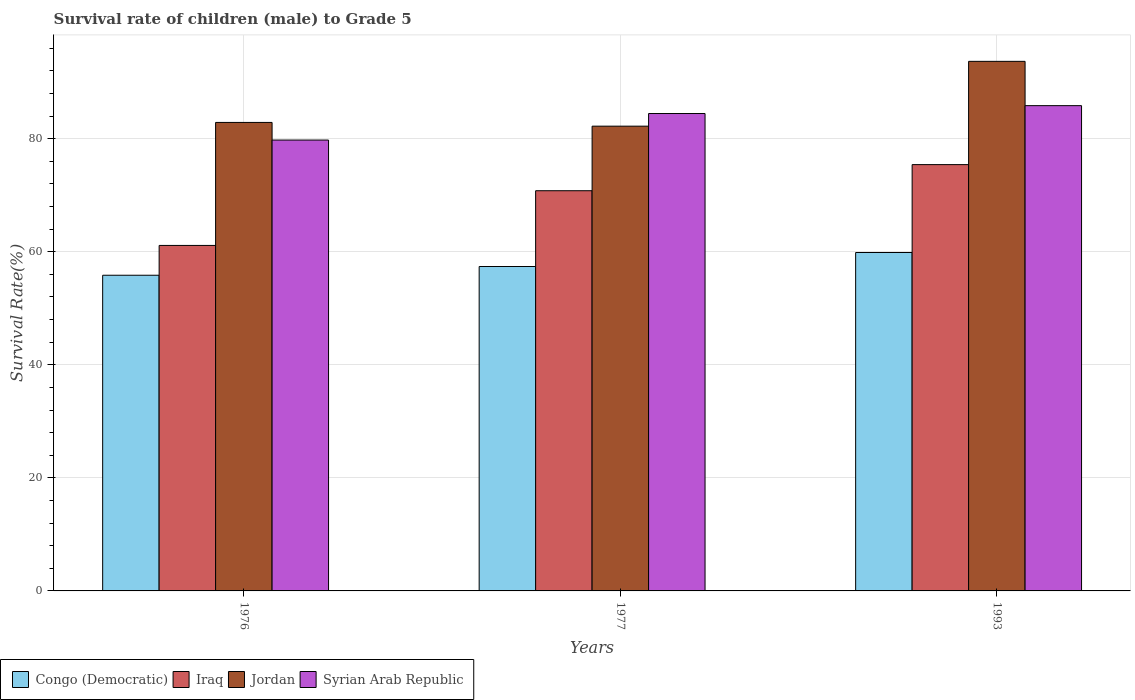How many different coloured bars are there?
Your answer should be very brief. 4. How many groups of bars are there?
Give a very brief answer. 3. How many bars are there on the 1st tick from the left?
Offer a terse response. 4. How many bars are there on the 3rd tick from the right?
Keep it short and to the point. 4. What is the label of the 2nd group of bars from the left?
Provide a short and direct response. 1977. In how many cases, is the number of bars for a given year not equal to the number of legend labels?
Provide a short and direct response. 0. What is the survival rate of male children to grade 5 in Congo (Democratic) in 1993?
Keep it short and to the point. 59.87. Across all years, what is the maximum survival rate of male children to grade 5 in Iraq?
Give a very brief answer. 75.42. Across all years, what is the minimum survival rate of male children to grade 5 in Jordan?
Your response must be concise. 82.22. In which year was the survival rate of male children to grade 5 in Syrian Arab Republic minimum?
Ensure brevity in your answer.  1976. What is the total survival rate of male children to grade 5 in Jordan in the graph?
Ensure brevity in your answer.  258.78. What is the difference between the survival rate of male children to grade 5 in Congo (Democratic) in 1976 and that in 1977?
Provide a short and direct response. -1.55. What is the difference between the survival rate of male children to grade 5 in Congo (Democratic) in 1993 and the survival rate of male children to grade 5 in Jordan in 1976?
Give a very brief answer. -23.01. What is the average survival rate of male children to grade 5 in Syrian Arab Republic per year?
Make the answer very short. 83.35. In the year 1977, what is the difference between the survival rate of male children to grade 5 in Syrian Arab Republic and survival rate of male children to grade 5 in Jordan?
Your response must be concise. 2.24. In how many years, is the survival rate of male children to grade 5 in Iraq greater than 12 %?
Your response must be concise. 3. What is the ratio of the survival rate of male children to grade 5 in Congo (Democratic) in 1976 to that in 1977?
Make the answer very short. 0.97. Is the survival rate of male children to grade 5 in Iraq in 1976 less than that in 1977?
Provide a succinct answer. Yes. Is the difference between the survival rate of male children to grade 5 in Syrian Arab Republic in 1977 and 1993 greater than the difference between the survival rate of male children to grade 5 in Jordan in 1977 and 1993?
Offer a terse response. Yes. What is the difference between the highest and the second highest survival rate of male children to grade 5 in Iraq?
Your response must be concise. 4.62. What is the difference between the highest and the lowest survival rate of male children to grade 5 in Iraq?
Offer a very short reply. 14.3. In how many years, is the survival rate of male children to grade 5 in Syrian Arab Republic greater than the average survival rate of male children to grade 5 in Syrian Arab Republic taken over all years?
Your answer should be compact. 2. Is the sum of the survival rate of male children to grade 5 in Syrian Arab Republic in 1976 and 1977 greater than the maximum survival rate of male children to grade 5 in Congo (Democratic) across all years?
Your response must be concise. Yes. What does the 4th bar from the left in 1993 represents?
Provide a short and direct response. Syrian Arab Republic. What does the 3rd bar from the right in 1977 represents?
Give a very brief answer. Iraq. How many bars are there?
Offer a terse response. 12. Are all the bars in the graph horizontal?
Offer a terse response. No. How many years are there in the graph?
Make the answer very short. 3. Are the values on the major ticks of Y-axis written in scientific E-notation?
Your response must be concise. No. Does the graph contain any zero values?
Make the answer very short. No. How many legend labels are there?
Offer a terse response. 4. What is the title of the graph?
Your answer should be very brief. Survival rate of children (male) to Grade 5. Does "Cameroon" appear as one of the legend labels in the graph?
Your answer should be compact. No. What is the label or title of the Y-axis?
Your response must be concise. Survival Rate(%). What is the Survival Rate(%) of Congo (Democratic) in 1976?
Your answer should be compact. 55.84. What is the Survival Rate(%) in Iraq in 1976?
Provide a short and direct response. 61.12. What is the Survival Rate(%) of Jordan in 1976?
Make the answer very short. 82.88. What is the Survival Rate(%) of Syrian Arab Republic in 1976?
Provide a succinct answer. 79.76. What is the Survival Rate(%) in Congo (Democratic) in 1977?
Offer a very short reply. 57.39. What is the Survival Rate(%) of Iraq in 1977?
Provide a succinct answer. 70.8. What is the Survival Rate(%) in Jordan in 1977?
Offer a very short reply. 82.22. What is the Survival Rate(%) of Syrian Arab Republic in 1977?
Provide a succinct answer. 84.45. What is the Survival Rate(%) in Congo (Democratic) in 1993?
Keep it short and to the point. 59.87. What is the Survival Rate(%) in Iraq in 1993?
Your answer should be compact. 75.42. What is the Survival Rate(%) in Jordan in 1993?
Your answer should be very brief. 93.68. What is the Survival Rate(%) of Syrian Arab Republic in 1993?
Offer a very short reply. 85.85. Across all years, what is the maximum Survival Rate(%) of Congo (Democratic)?
Provide a short and direct response. 59.87. Across all years, what is the maximum Survival Rate(%) of Iraq?
Keep it short and to the point. 75.42. Across all years, what is the maximum Survival Rate(%) in Jordan?
Provide a short and direct response. 93.68. Across all years, what is the maximum Survival Rate(%) of Syrian Arab Republic?
Provide a succinct answer. 85.85. Across all years, what is the minimum Survival Rate(%) in Congo (Democratic)?
Your answer should be very brief. 55.84. Across all years, what is the minimum Survival Rate(%) in Iraq?
Offer a very short reply. 61.12. Across all years, what is the minimum Survival Rate(%) of Jordan?
Offer a very short reply. 82.22. Across all years, what is the minimum Survival Rate(%) of Syrian Arab Republic?
Make the answer very short. 79.76. What is the total Survival Rate(%) in Congo (Democratic) in the graph?
Your answer should be compact. 173.1. What is the total Survival Rate(%) of Iraq in the graph?
Make the answer very short. 207.33. What is the total Survival Rate(%) of Jordan in the graph?
Ensure brevity in your answer.  258.78. What is the total Survival Rate(%) of Syrian Arab Republic in the graph?
Give a very brief answer. 250.06. What is the difference between the Survival Rate(%) of Congo (Democratic) in 1976 and that in 1977?
Give a very brief answer. -1.55. What is the difference between the Survival Rate(%) of Iraq in 1976 and that in 1977?
Ensure brevity in your answer.  -9.68. What is the difference between the Survival Rate(%) in Jordan in 1976 and that in 1977?
Your answer should be very brief. 0.66. What is the difference between the Survival Rate(%) in Syrian Arab Republic in 1976 and that in 1977?
Ensure brevity in your answer.  -4.69. What is the difference between the Survival Rate(%) of Congo (Democratic) in 1976 and that in 1993?
Provide a succinct answer. -4.02. What is the difference between the Survival Rate(%) of Iraq in 1976 and that in 1993?
Provide a short and direct response. -14.3. What is the difference between the Survival Rate(%) of Jordan in 1976 and that in 1993?
Keep it short and to the point. -10.81. What is the difference between the Survival Rate(%) of Syrian Arab Republic in 1976 and that in 1993?
Provide a succinct answer. -6.09. What is the difference between the Survival Rate(%) in Congo (Democratic) in 1977 and that in 1993?
Give a very brief answer. -2.48. What is the difference between the Survival Rate(%) in Iraq in 1977 and that in 1993?
Your answer should be compact. -4.62. What is the difference between the Survival Rate(%) in Jordan in 1977 and that in 1993?
Your answer should be very brief. -11.46. What is the difference between the Survival Rate(%) of Syrian Arab Republic in 1977 and that in 1993?
Your answer should be very brief. -1.39. What is the difference between the Survival Rate(%) in Congo (Democratic) in 1976 and the Survival Rate(%) in Iraq in 1977?
Your response must be concise. -14.95. What is the difference between the Survival Rate(%) in Congo (Democratic) in 1976 and the Survival Rate(%) in Jordan in 1977?
Your answer should be very brief. -26.37. What is the difference between the Survival Rate(%) in Congo (Democratic) in 1976 and the Survival Rate(%) in Syrian Arab Republic in 1977?
Offer a terse response. -28.61. What is the difference between the Survival Rate(%) in Iraq in 1976 and the Survival Rate(%) in Jordan in 1977?
Offer a terse response. -21.1. What is the difference between the Survival Rate(%) in Iraq in 1976 and the Survival Rate(%) in Syrian Arab Republic in 1977?
Provide a short and direct response. -23.34. What is the difference between the Survival Rate(%) of Jordan in 1976 and the Survival Rate(%) of Syrian Arab Republic in 1977?
Your answer should be compact. -1.58. What is the difference between the Survival Rate(%) in Congo (Democratic) in 1976 and the Survival Rate(%) in Iraq in 1993?
Your answer should be very brief. -19.57. What is the difference between the Survival Rate(%) of Congo (Democratic) in 1976 and the Survival Rate(%) of Jordan in 1993?
Ensure brevity in your answer.  -37.84. What is the difference between the Survival Rate(%) of Congo (Democratic) in 1976 and the Survival Rate(%) of Syrian Arab Republic in 1993?
Your answer should be compact. -30. What is the difference between the Survival Rate(%) of Iraq in 1976 and the Survival Rate(%) of Jordan in 1993?
Offer a terse response. -32.56. What is the difference between the Survival Rate(%) of Iraq in 1976 and the Survival Rate(%) of Syrian Arab Republic in 1993?
Your answer should be compact. -24.73. What is the difference between the Survival Rate(%) of Jordan in 1976 and the Survival Rate(%) of Syrian Arab Republic in 1993?
Your response must be concise. -2.97. What is the difference between the Survival Rate(%) of Congo (Democratic) in 1977 and the Survival Rate(%) of Iraq in 1993?
Offer a terse response. -18.03. What is the difference between the Survival Rate(%) of Congo (Democratic) in 1977 and the Survival Rate(%) of Jordan in 1993?
Ensure brevity in your answer.  -36.29. What is the difference between the Survival Rate(%) in Congo (Democratic) in 1977 and the Survival Rate(%) in Syrian Arab Republic in 1993?
Your answer should be very brief. -28.46. What is the difference between the Survival Rate(%) in Iraq in 1977 and the Survival Rate(%) in Jordan in 1993?
Ensure brevity in your answer.  -22.89. What is the difference between the Survival Rate(%) in Iraq in 1977 and the Survival Rate(%) in Syrian Arab Republic in 1993?
Ensure brevity in your answer.  -15.05. What is the difference between the Survival Rate(%) of Jordan in 1977 and the Survival Rate(%) of Syrian Arab Republic in 1993?
Offer a very short reply. -3.63. What is the average Survival Rate(%) of Congo (Democratic) per year?
Make the answer very short. 57.7. What is the average Survival Rate(%) in Iraq per year?
Keep it short and to the point. 69.11. What is the average Survival Rate(%) in Jordan per year?
Make the answer very short. 86.26. What is the average Survival Rate(%) of Syrian Arab Republic per year?
Your answer should be very brief. 83.35. In the year 1976, what is the difference between the Survival Rate(%) of Congo (Democratic) and Survival Rate(%) of Iraq?
Provide a succinct answer. -5.27. In the year 1976, what is the difference between the Survival Rate(%) in Congo (Democratic) and Survival Rate(%) in Jordan?
Ensure brevity in your answer.  -27.03. In the year 1976, what is the difference between the Survival Rate(%) in Congo (Democratic) and Survival Rate(%) in Syrian Arab Republic?
Ensure brevity in your answer.  -23.92. In the year 1976, what is the difference between the Survival Rate(%) of Iraq and Survival Rate(%) of Jordan?
Give a very brief answer. -21.76. In the year 1976, what is the difference between the Survival Rate(%) of Iraq and Survival Rate(%) of Syrian Arab Republic?
Your answer should be compact. -18.64. In the year 1976, what is the difference between the Survival Rate(%) in Jordan and Survival Rate(%) in Syrian Arab Republic?
Provide a short and direct response. 3.12. In the year 1977, what is the difference between the Survival Rate(%) in Congo (Democratic) and Survival Rate(%) in Iraq?
Offer a terse response. -13.41. In the year 1977, what is the difference between the Survival Rate(%) of Congo (Democratic) and Survival Rate(%) of Jordan?
Your answer should be compact. -24.83. In the year 1977, what is the difference between the Survival Rate(%) in Congo (Democratic) and Survival Rate(%) in Syrian Arab Republic?
Provide a short and direct response. -27.06. In the year 1977, what is the difference between the Survival Rate(%) of Iraq and Survival Rate(%) of Jordan?
Offer a terse response. -11.42. In the year 1977, what is the difference between the Survival Rate(%) in Iraq and Survival Rate(%) in Syrian Arab Republic?
Your response must be concise. -13.66. In the year 1977, what is the difference between the Survival Rate(%) of Jordan and Survival Rate(%) of Syrian Arab Republic?
Provide a short and direct response. -2.24. In the year 1993, what is the difference between the Survival Rate(%) of Congo (Democratic) and Survival Rate(%) of Iraq?
Ensure brevity in your answer.  -15.55. In the year 1993, what is the difference between the Survival Rate(%) in Congo (Democratic) and Survival Rate(%) in Jordan?
Offer a terse response. -33.82. In the year 1993, what is the difference between the Survival Rate(%) of Congo (Democratic) and Survival Rate(%) of Syrian Arab Republic?
Provide a succinct answer. -25.98. In the year 1993, what is the difference between the Survival Rate(%) in Iraq and Survival Rate(%) in Jordan?
Give a very brief answer. -18.27. In the year 1993, what is the difference between the Survival Rate(%) in Iraq and Survival Rate(%) in Syrian Arab Republic?
Make the answer very short. -10.43. In the year 1993, what is the difference between the Survival Rate(%) of Jordan and Survival Rate(%) of Syrian Arab Republic?
Offer a very short reply. 7.84. What is the ratio of the Survival Rate(%) in Congo (Democratic) in 1976 to that in 1977?
Offer a very short reply. 0.97. What is the ratio of the Survival Rate(%) in Iraq in 1976 to that in 1977?
Keep it short and to the point. 0.86. What is the ratio of the Survival Rate(%) in Congo (Democratic) in 1976 to that in 1993?
Offer a very short reply. 0.93. What is the ratio of the Survival Rate(%) of Iraq in 1976 to that in 1993?
Your response must be concise. 0.81. What is the ratio of the Survival Rate(%) of Jordan in 1976 to that in 1993?
Offer a terse response. 0.88. What is the ratio of the Survival Rate(%) of Syrian Arab Republic in 1976 to that in 1993?
Keep it short and to the point. 0.93. What is the ratio of the Survival Rate(%) in Congo (Democratic) in 1977 to that in 1993?
Offer a terse response. 0.96. What is the ratio of the Survival Rate(%) in Iraq in 1977 to that in 1993?
Ensure brevity in your answer.  0.94. What is the ratio of the Survival Rate(%) in Jordan in 1977 to that in 1993?
Your answer should be compact. 0.88. What is the ratio of the Survival Rate(%) in Syrian Arab Republic in 1977 to that in 1993?
Keep it short and to the point. 0.98. What is the difference between the highest and the second highest Survival Rate(%) of Congo (Democratic)?
Your response must be concise. 2.48. What is the difference between the highest and the second highest Survival Rate(%) in Iraq?
Give a very brief answer. 4.62. What is the difference between the highest and the second highest Survival Rate(%) of Jordan?
Your answer should be compact. 10.81. What is the difference between the highest and the second highest Survival Rate(%) of Syrian Arab Republic?
Give a very brief answer. 1.39. What is the difference between the highest and the lowest Survival Rate(%) of Congo (Democratic)?
Your answer should be very brief. 4.02. What is the difference between the highest and the lowest Survival Rate(%) in Iraq?
Offer a terse response. 14.3. What is the difference between the highest and the lowest Survival Rate(%) of Jordan?
Provide a succinct answer. 11.46. What is the difference between the highest and the lowest Survival Rate(%) of Syrian Arab Republic?
Your answer should be compact. 6.09. 